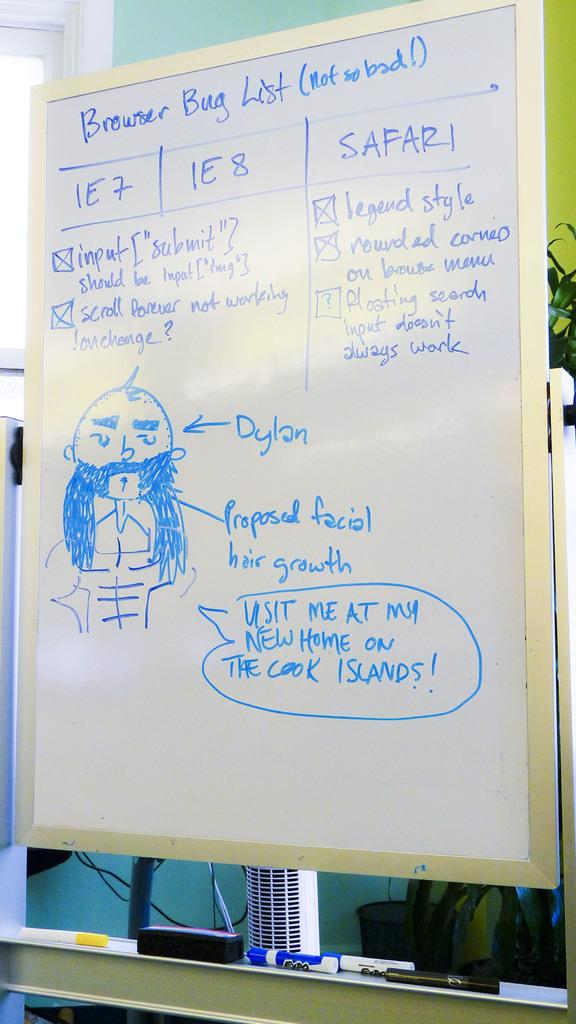<image>
Present a compact description of the photo's key features. Someone has drawn a picture of Dylan on the board and labeled it. 